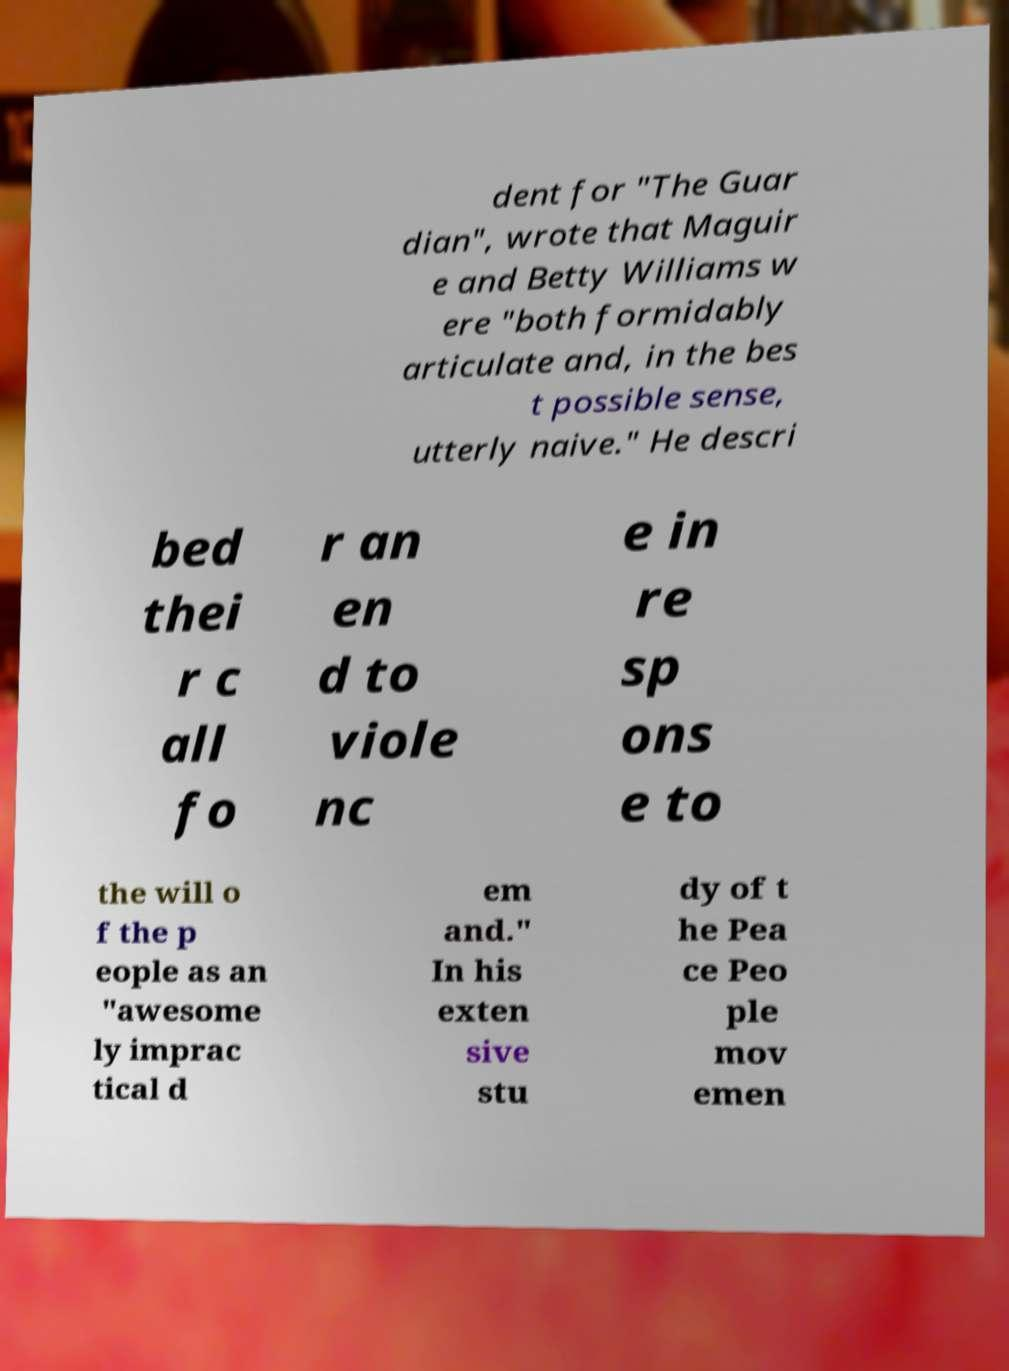Can you accurately transcribe the text from the provided image for me? dent for "The Guar dian", wrote that Maguir e and Betty Williams w ere "both formidably articulate and, in the bes t possible sense, utterly naive." He descri bed thei r c all fo r an en d to viole nc e in re sp ons e to the will o f the p eople as an "awesome ly imprac tical d em and." In his exten sive stu dy of t he Pea ce Peo ple mov emen 